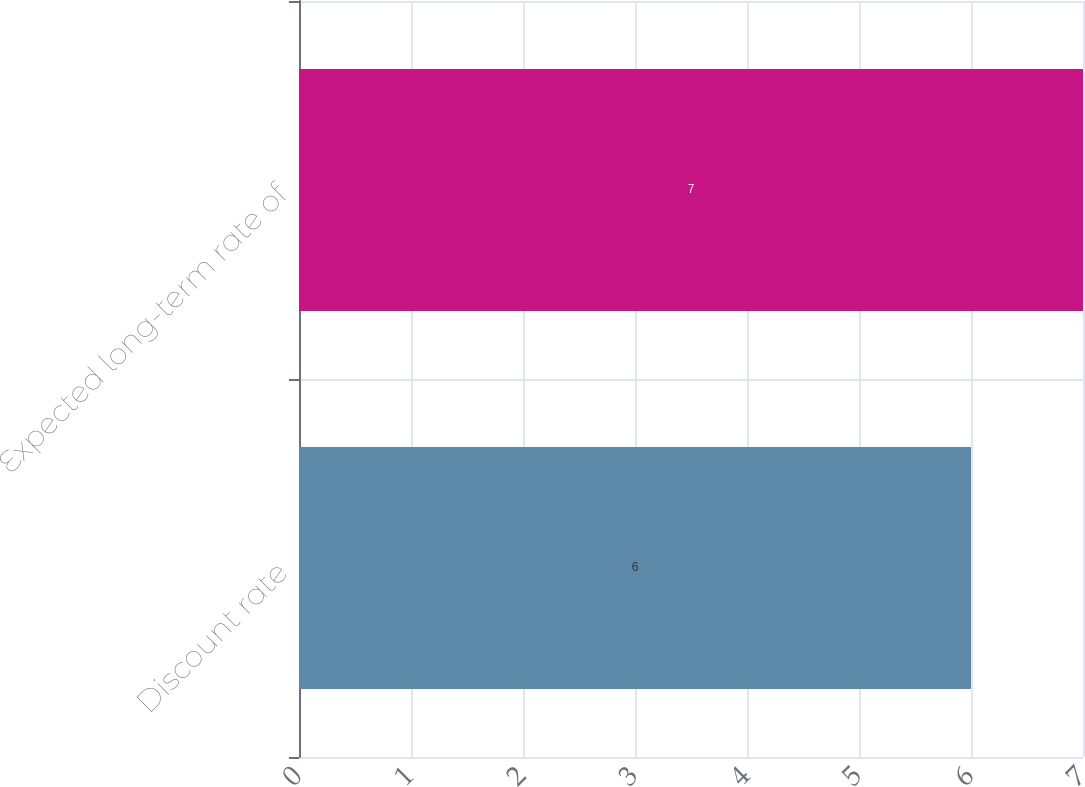Convert chart. <chart><loc_0><loc_0><loc_500><loc_500><bar_chart><fcel>Discount rate<fcel>Expected long-term rate of<nl><fcel>6<fcel>7<nl></chart> 